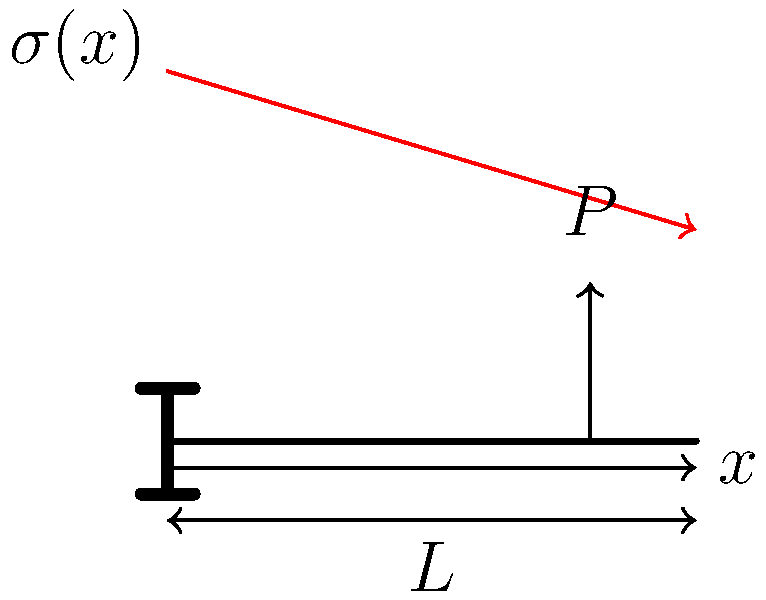A cantilever beam of length $L$ is subjected to a point load $P$ at its free end. Given that the beam has a rectangular cross-section with width $b$ and height $h$, derive an expression for the maximum normal stress $\sigma_{max}$ at the fixed end in terms of $P$, $L$, $b$, and $h$. Additionally, explain how the stress varies along the length of the beam. To solve this problem, we'll follow these steps:

1) The maximum bending moment $M_{max}$ occurs at the fixed end:
   $$M_{max} = PL$$

2) The moment of inertia $I$ for a rectangular cross-section is:
   $$I = \frac{bh^3}{12}$$

3) The maximum stress occurs at the outermost fibers, where $y = h/2$:
   $$\sigma_{max} = \frac{My}{I}$$

4) Substituting the values:
   $$\sigma_{max} = \frac{PL(h/2)}{\frac{bh^3}{12}}$$

5) Simplifying:
   $$\sigma_{max} = \frac{6PL}{bh^2}$$

6) The stress variation along the beam's length follows a linear distribution:
   $$\sigma(x) = \frac{6P(L-x)}{bh^2}$$
   where $x$ is the distance from the fixed end.

7) At $x = 0$ (fixed end), $\sigma = \sigma_{max}$
   At $x = L$ (free end), $\sigma = 0$

The stress distribution is maximum at the fixed end and decreases linearly to zero at the free end, as shown in the red line in the diagram.
Answer: $\sigma_{max} = \frac{6PL}{bh^2}$; Stress varies linearly from maximum at fixed end to zero at free end. 